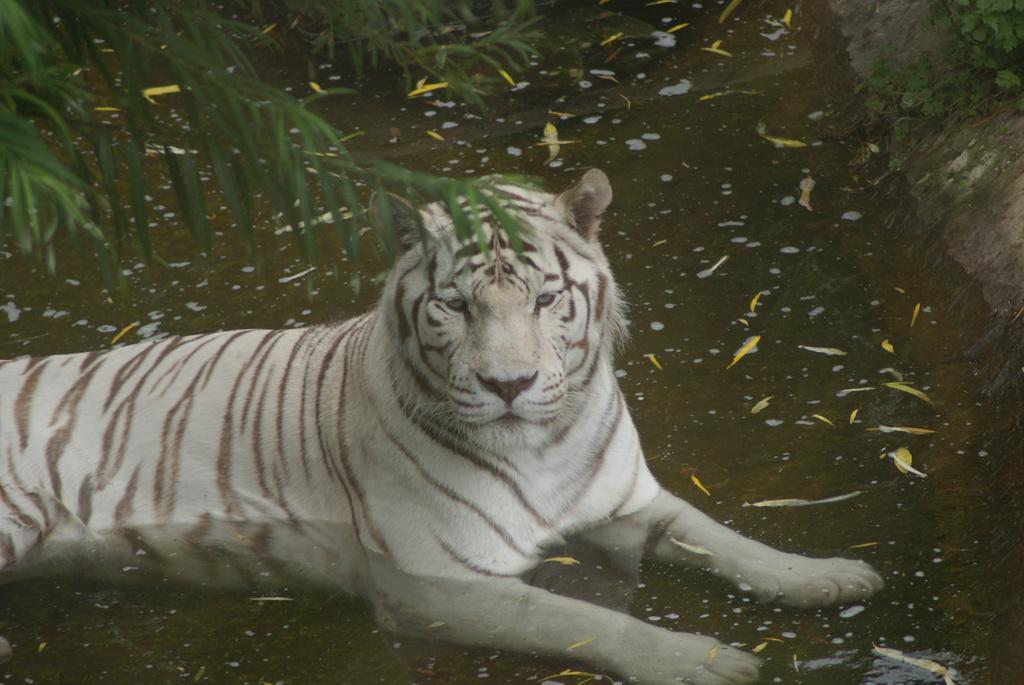What type of animal is in the image? There is a white tiger in the image. Where is the tiger located in the image? The tiger is sitting in the water. What other elements can be seen in the image besides the tiger? There are plants and plant saplings in the image. How many suns can be seen in the image? There are no suns visible in the image. Are there any lizards present in the image? There is no mention of lizards in the provided facts, so we cannot determine their presence in the image. 